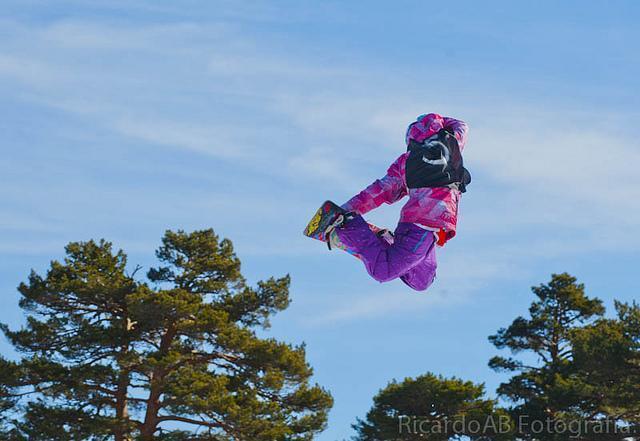How many people are there?
Give a very brief answer. 1. How many wheels does the skateboard have?
Give a very brief answer. 0. 